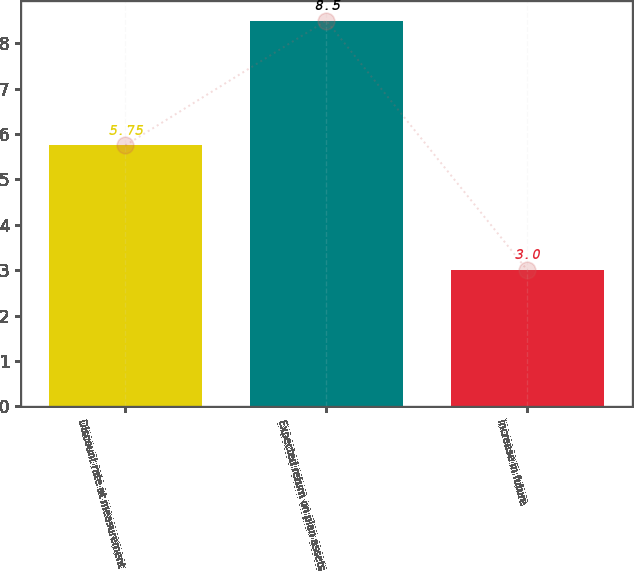Convert chart. <chart><loc_0><loc_0><loc_500><loc_500><bar_chart><fcel>Discount rate at measurement<fcel>Expected return on plan assets<fcel>Increase in future<nl><fcel>5.75<fcel>8.5<fcel>3<nl></chart> 